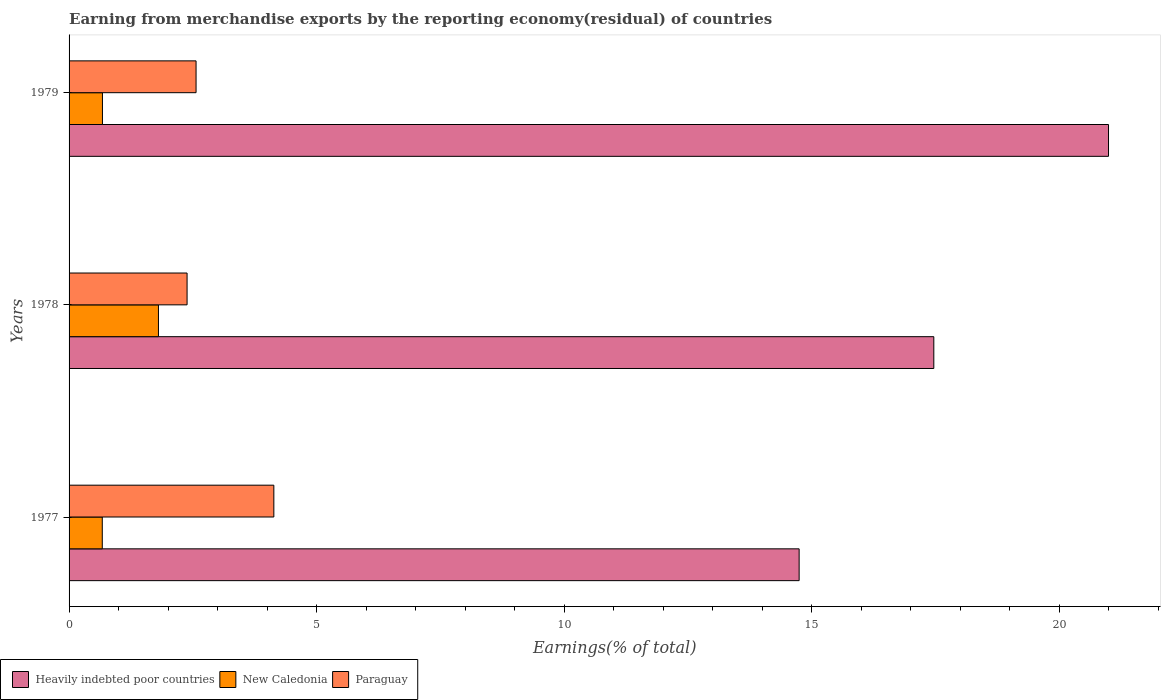How many groups of bars are there?
Your answer should be compact. 3. Are the number of bars on each tick of the Y-axis equal?
Give a very brief answer. Yes. How many bars are there on the 3rd tick from the bottom?
Give a very brief answer. 3. What is the label of the 3rd group of bars from the top?
Ensure brevity in your answer.  1977. What is the percentage of amount earned from merchandise exports in New Caledonia in 1979?
Your response must be concise. 0.67. Across all years, what is the maximum percentage of amount earned from merchandise exports in Paraguay?
Keep it short and to the point. 4.14. Across all years, what is the minimum percentage of amount earned from merchandise exports in New Caledonia?
Make the answer very short. 0.67. In which year was the percentage of amount earned from merchandise exports in New Caledonia maximum?
Give a very brief answer. 1978. In which year was the percentage of amount earned from merchandise exports in New Caledonia minimum?
Your answer should be compact. 1977. What is the total percentage of amount earned from merchandise exports in Heavily indebted poor countries in the graph?
Offer a terse response. 53.22. What is the difference between the percentage of amount earned from merchandise exports in New Caledonia in 1977 and that in 1979?
Your response must be concise. -0. What is the difference between the percentage of amount earned from merchandise exports in Paraguay in 1979 and the percentage of amount earned from merchandise exports in Heavily indebted poor countries in 1977?
Your response must be concise. -12.18. What is the average percentage of amount earned from merchandise exports in New Caledonia per year?
Your response must be concise. 1.05. In the year 1978, what is the difference between the percentage of amount earned from merchandise exports in Heavily indebted poor countries and percentage of amount earned from merchandise exports in New Caledonia?
Ensure brevity in your answer.  15.66. What is the ratio of the percentage of amount earned from merchandise exports in Paraguay in 1978 to that in 1979?
Give a very brief answer. 0.93. Is the percentage of amount earned from merchandise exports in Paraguay in 1977 less than that in 1978?
Keep it short and to the point. No. Is the difference between the percentage of amount earned from merchandise exports in Heavily indebted poor countries in 1977 and 1978 greater than the difference between the percentage of amount earned from merchandise exports in New Caledonia in 1977 and 1978?
Your response must be concise. No. What is the difference between the highest and the second highest percentage of amount earned from merchandise exports in New Caledonia?
Your answer should be compact. 1.13. What is the difference between the highest and the lowest percentage of amount earned from merchandise exports in Paraguay?
Give a very brief answer. 1.75. In how many years, is the percentage of amount earned from merchandise exports in Paraguay greater than the average percentage of amount earned from merchandise exports in Paraguay taken over all years?
Ensure brevity in your answer.  1. Is the sum of the percentage of amount earned from merchandise exports in Heavily indebted poor countries in 1978 and 1979 greater than the maximum percentage of amount earned from merchandise exports in Paraguay across all years?
Your answer should be very brief. Yes. What does the 2nd bar from the top in 1977 represents?
Your answer should be compact. New Caledonia. What does the 2nd bar from the bottom in 1978 represents?
Provide a succinct answer. New Caledonia. Is it the case that in every year, the sum of the percentage of amount earned from merchandise exports in Paraguay and percentage of amount earned from merchandise exports in Heavily indebted poor countries is greater than the percentage of amount earned from merchandise exports in New Caledonia?
Offer a very short reply. Yes. How many bars are there?
Offer a very short reply. 9. Are all the bars in the graph horizontal?
Make the answer very short. Yes. How many years are there in the graph?
Make the answer very short. 3. What is the difference between two consecutive major ticks on the X-axis?
Your answer should be compact. 5. Are the values on the major ticks of X-axis written in scientific E-notation?
Your answer should be compact. No. Where does the legend appear in the graph?
Provide a short and direct response. Bottom left. What is the title of the graph?
Give a very brief answer. Earning from merchandise exports by the reporting economy(residual) of countries. Does "Romania" appear as one of the legend labels in the graph?
Your response must be concise. No. What is the label or title of the X-axis?
Your answer should be very brief. Earnings(% of total). What is the label or title of the Y-axis?
Make the answer very short. Years. What is the Earnings(% of total) in Heavily indebted poor countries in 1977?
Your answer should be very brief. 14.75. What is the Earnings(% of total) of New Caledonia in 1977?
Give a very brief answer. 0.67. What is the Earnings(% of total) of Paraguay in 1977?
Your answer should be very brief. 4.14. What is the Earnings(% of total) of Heavily indebted poor countries in 1978?
Offer a terse response. 17.47. What is the Earnings(% of total) of New Caledonia in 1978?
Ensure brevity in your answer.  1.81. What is the Earnings(% of total) of Paraguay in 1978?
Your response must be concise. 2.38. What is the Earnings(% of total) in Heavily indebted poor countries in 1979?
Offer a very short reply. 21. What is the Earnings(% of total) in New Caledonia in 1979?
Make the answer very short. 0.67. What is the Earnings(% of total) in Paraguay in 1979?
Your answer should be compact. 2.57. Across all years, what is the maximum Earnings(% of total) of Heavily indebted poor countries?
Offer a terse response. 21. Across all years, what is the maximum Earnings(% of total) in New Caledonia?
Your answer should be compact. 1.81. Across all years, what is the maximum Earnings(% of total) in Paraguay?
Give a very brief answer. 4.14. Across all years, what is the minimum Earnings(% of total) in Heavily indebted poor countries?
Your response must be concise. 14.75. Across all years, what is the minimum Earnings(% of total) in New Caledonia?
Ensure brevity in your answer.  0.67. Across all years, what is the minimum Earnings(% of total) of Paraguay?
Your response must be concise. 2.38. What is the total Earnings(% of total) in Heavily indebted poor countries in the graph?
Provide a succinct answer. 53.22. What is the total Earnings(% of total) of New Caledonia in the graph?
Give a very brief answer. 3.15. What is the total Earnings(% of total) in Paraguay in the graph?
Give a very brief answer. 9.09. What is the difference between the Earnings(% of total) of Heavily indebted poor countries in 1977 and that in 1978?
Your answer should be very brief. -2.72. What is the difference between the Earnings(% of total) of New Caledonia in 1977 and that in 1978?
Provide a succinct answer. -1.13. What is the difference between the Earnings(% of total) of Paraguay in 1977 and that in 1978?
Make the answer very short. 1.75. What is the difference between the Earnings(% of total) of Heavily indebted poor countries in 1977 and that in 1979?
Provide a succinct answer. -6.25. What is the difference between the Earnings(% of total) in New Caledonia in 1977 and that in 1979?
Give a very brief answer. -0. What is the difference between the Earnings(% of total) in Paraguay in 1977 and that in 1979?
Offer a terse response. 1.57. What is the difference between the Earnings(% of total) in Heavily indebted poor countries in 1978 and that in 1979?
Keep it short and to the point. -3.53. What is the difference between the Earnings(% of total) in New Caledonia in 1978 and that in 1979?
Ensure brevity in your answer.  1.13. What is the difference between the Earnings(% of total) of Paraguay in 1978 and that in 1979?
Provide a succinct answer. -0.18. What is the difference between the Earnings(% of total) in Heavily indebted poor countries in 1977 and the Earnings(% of total) in New Caledonia in 1978?
Provide a short and direct response. 12.94. What is the difference between the Earnings(% of total) in Heavily indebted poor countries in 1977 and the Earnings(% of total) in Paraguay in 1978?
Make the answer very short. 12.37. What is the difference between the Earnings(% of total) in New Caledonia in 1977 and the Earnings(% of total) in Paraguay in 1978?
Your answer should be very brief. -1.71. What is the difference between the Earnings(% of total) in Heavily indebted poor countries in 1977 and the Earnings(% of total) in New Caledonia in 1979?
Offer a very short reply. 14.07. What is the difference between the Earnings(% of total) in Heavily indebted poor countries in 1977 and the Earnings(% of total) in Paraguay in 1979?
Your response must be concise. 12.18. What is the difference between the Earnings(% of total) of New Caledonia in 1977 and the Earnings(% of total) of Paraguay in 1979?
Ensure brevity in your answer.  -1.89. What is the difference between the Earnings(% of total) of Heavily indebted poor countries in 1978 and the Earnings(% of total) of New Caledonia in 1979?
Keep it short and to the point. 16.8. What is the difference between the Earnings(% of total) in Heavily indebted poor countries in 1978 and the Earnings(% of total) in Paraguay in 1979?
Give a very brief answer. 14.9. What is the difference between the Earnings(% of total) of New Caledonia in 1978 and the Earnings(% of total) of Paraguay in 1979?
Your answer should be very brief. -0.76. What is the average Earnings(% of total) of Heavily indebted poor countries per year?
Your answer should be very brief. 17.74. What is the average Earnings(% of total) in New Caledonia per year?
Keep it short and to the point. 1.05. What is the average Earnings(% of total) of Paraguay per year?
Your response must be concise. 3.03. In the year 1977, what is the difference between the Earnings(% of total) in Heavily indebted poor countries and Earnings(% of total) in New Caledonia?
Give a very brief answer. 14.08. In the year 1977, what is the difference between the Earnings(% of total) of Heavily indebted poor countries and Earnings(% of total) of Paraguay?
Provide a short and direct response. 10.61. In the year 1977, what is the difference between the Earnings(% of total) of New Caledonia and Earnings(% of total) of Paraguay?
Offer a very short reply. -3.47. In the year 1978, what is the difference between the Earnings(% of total) in Heavily indebted poor countries and Earnings(% of total) in New Caledonia?
Ensure brevity in your answer.  15.66. In the year 1978, what is the difference between the Earnings(% of total) of Heavily indebted poor countries and Earnings(% of total) of Paraguay?
Your answer should be very brief. 15.09. In the year 1978, what is the difference between the Earnings(% of total) in New Caledonia and Earnings(% of total) in Paraguay?
Give a very brief answer. -0.58. In the year 1979, what is the difference between the Earnings(% of total) of Heavily indebted poor countries and Earnings(% of total) of New Caledonia?
Keep it short and to the point. 20.32. In the year 1979, what is the difference between the Earnings(% of total) of Heavily indebted poor countries and Earnings(% of total) of Paraguay?
Offer a very short reply. 18.43. In the year 1979, what is the difference between the Earnings(% of total) of New Caledonia and Earnings(% of total) of Paraguay?
Make the answer very short. -1.89. What is the ratio of the Earnings(% of total) of Heavily indebted poor countries in 1977 to that in 1978?
Make the answer very short. 0.84. What is the ratio of the Earnings(% of total) in New Caledonia in 1977 to that in 1978?
Give a very brief answer. 0.37. What is the ratio of the Earnings(% of total) of Paraguay in 1977 to that in 1978?
Your response must be concise. 1.74. What is the ratio of the Earnings(% of total) of Heavily indebted poor countries in 1977 to that in 1979?
Make the answer very short. 0.7. What is the ratio of the Earnings(% of total) in New Caledonia in 1977 to that in 1979?
Provide a short and direct response. 0.99. What is the ratio of the Earnings(% of total) of Paraguay in 1977 to that in 1979?
Make the answer very short. 1.61. What is the ratio of the Earnings(% of total) of Heavily indebted poor countries in 1978 to that in 1979?
Make the answer very short. 0.83. What is the ratio of the Earnings(% of total) of New Caledonia in 1978 to that in 1979?
Provide a succinct answer. 2.68. What is the ratio of the Earnings(% of total) in Paraguay in 1978 to that in 1979?
Ensure brevity in your answer.  0.93. What is the difference between the highest and the second highest Earnings(% of total) of Heavily indebted poor countries?
Offer a terse response. 3.53. What is the difference between the highest and the second highest Earnings(% of total) of New Caledonia?
Your answer should be compact. 1.13. What is the difference between the highest and the second highest Earnings(% of total) in Paraguay?
Keep it short and to the point. 1.57. What is the difference between the highest and the lowest Earnings(% of total) in Heavily indebted poor countries?
Your response must be concise. 6.25. What is the difference between the highest and the lowest Earnings(% of total) in New Caledonia?
Provide a short and direct response. 1.13. What is the difference between the highest and the lowest Earnings(% of total) of Paraguay?
Provide a short and direct response. 1.75. 